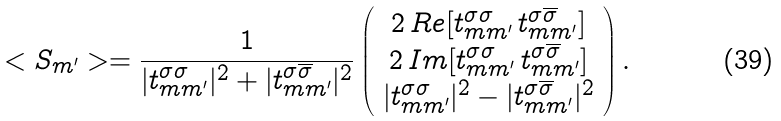Convert formula to latex. <formula><loc_0><loc_0><loc_500><loc_500>< S _ { m ^ { \prime } } > = \frac { 1 } { | t _ { m m ^ { \prime } } ^ { \sigma \sigma } | ^ { 2 } + | t _ { m m ^ { \prime } } ^ { \sigma \overline { \sigma } } | ^ { 2 } } \left ( \begin{array} { c } 2 \, R e [ t _ { m m ^ { \prime } } ^ { \sigma \sigma } \, t _ { m m ^ { \prime } } ^ { \sigma \overline { \sigma } } ] \\ 2 \, I m [ t _ { m m ^ { \prime } } ^ { \sigma \sigma } \, t _ { m m ^ { \prime } } ^ { \sigma \overline { \sigma } } ] \\ | t _ { m m ^ { \prime } } ^ { \sigma \sigma } | ^ { 2 } - | t _ { m m ^ { \prime } } ^ { \sigma \overline { \sigma } } | ^ { 2 } \end{array} \right ) .</formula> 